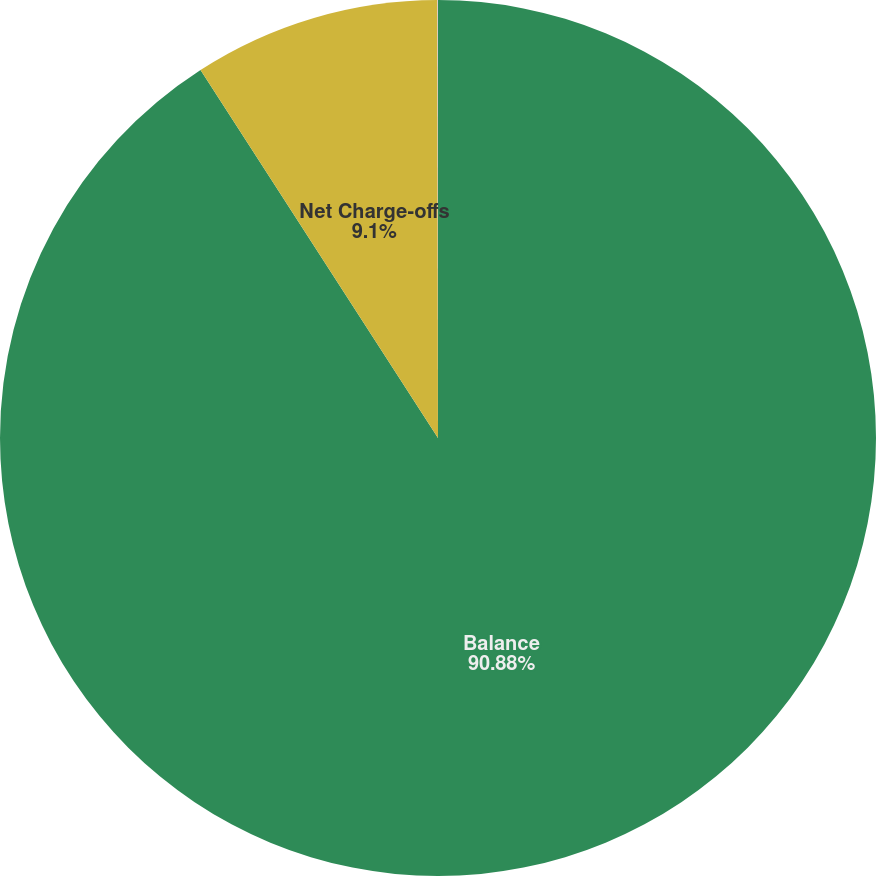<chart> <loc_0><loc_0><loc_500><loc_500><pie_chart><fcel>Balance<fcel>Net Charge-offs<fcel>Net Charge-off (1)<nl><fcel>90.88%<fcel>9.1%<fcel>0.02%<nl></chart> 